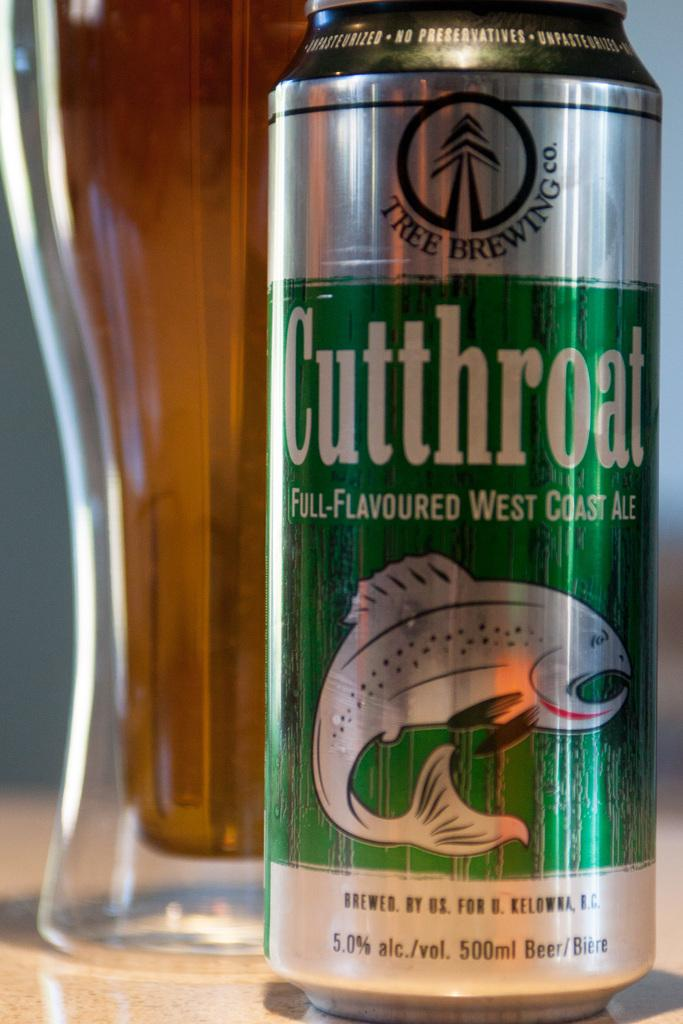<image>
Summarize the visual content of the image. A can of Cutthroat ale with a fish on the can is next to a glass. 